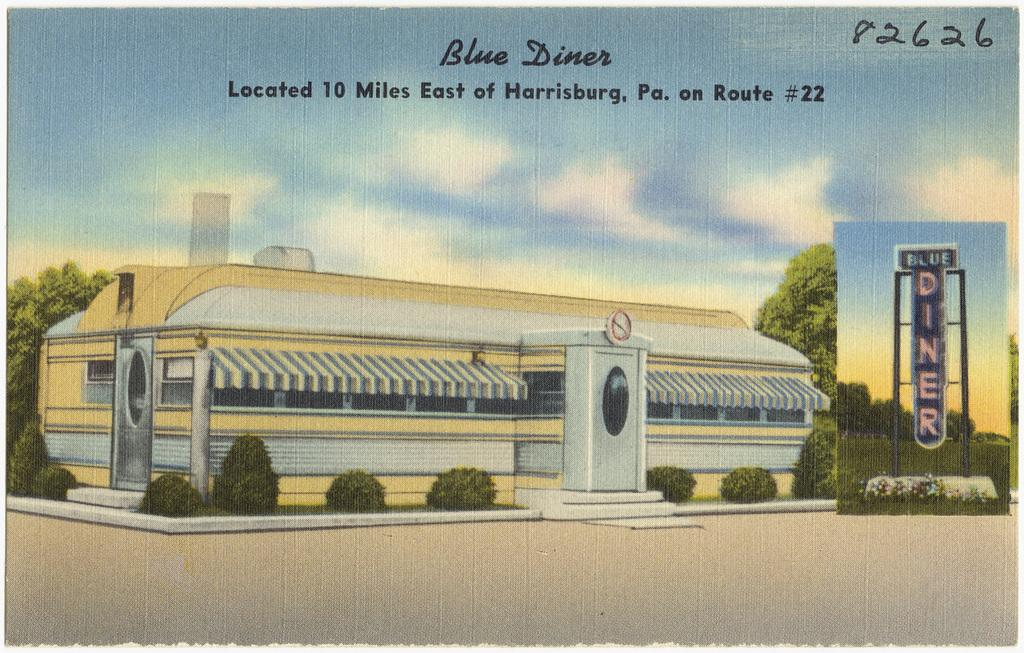<image>
Offer a succinct explanation of the picture presented. A painted diner with Blue Diner written above it in the clouds. 